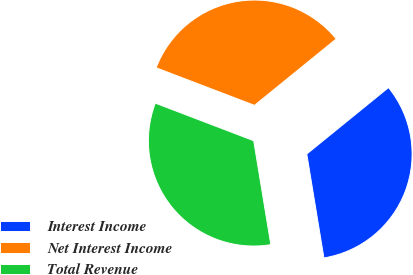Convert chart. <chart><loc_0><loc_0><loc_500><loc_500><pie_chart><fcel>Interest Income<fcel>Net Interest Income<fcel>Total Revenue<nl><fcel>33.26%<fcel>33.33%<fcel>33.41%<nl></chart> 